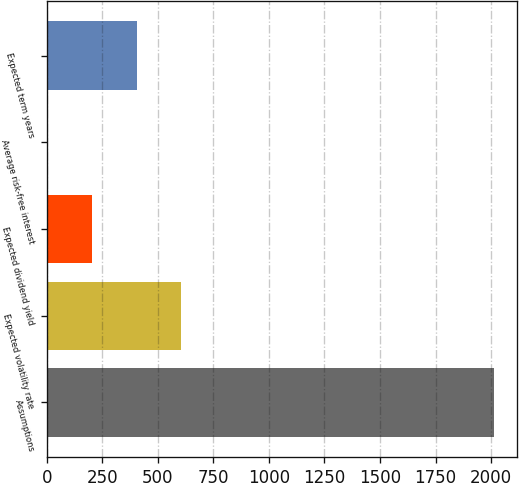Convert chart to OTSL. <chart><loc_0><loc_0><loc_500><loc_500><bar_chart><fcel>Assumptions<fcel>Expected volatility rate<fcel>Expected dividend yield<fcel>Average risk-free interest<fcel>Expected term years<nl><fcel>2015<fcel>605.53<fcel>202.81<fcel>1.45<fcel>404.17<nl></chart> 